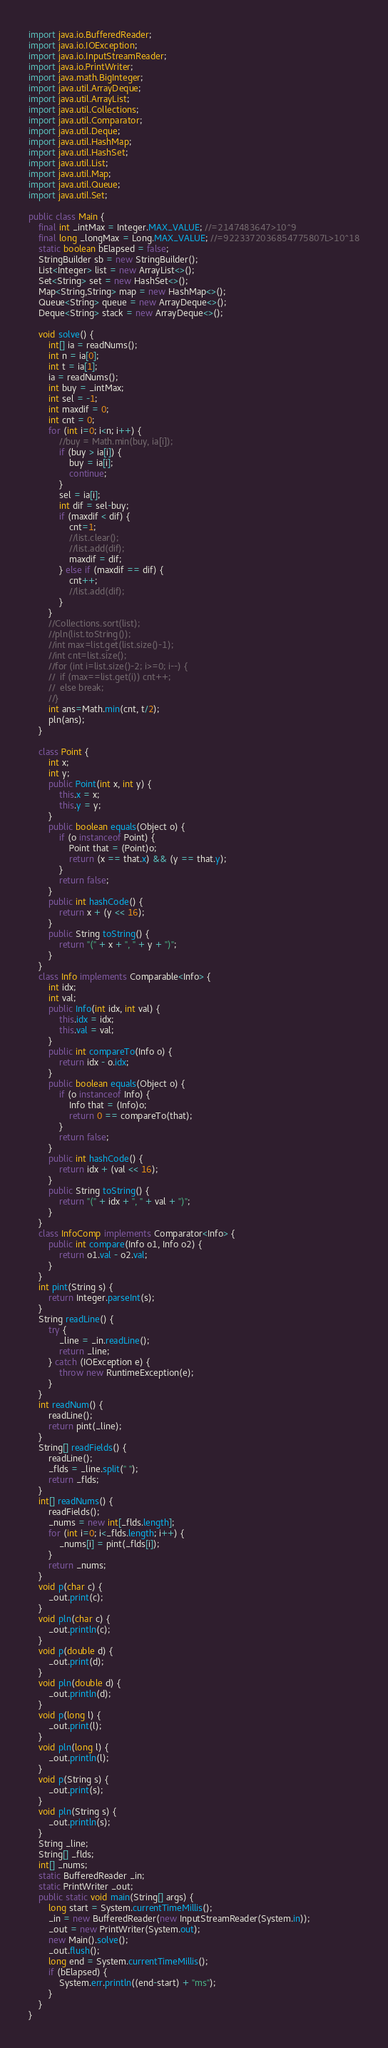<code> <loc_0><loc_0><loc_500><loc_500><_Java_>import java.io.BufferedReader;
import java.io.IOException;
import java.io.InputStreamReader;
import java.io.PrintWriter;
import java.math.BigInteger;
import java.util.ArrayDeque;
import java.util.ArrayList;
import java.util.Collections;
import java.util.Comparator;
import java.util.Deque;
import java.util.HashMap;
import java.util.HashSet;
import java.util.List;
import java.util.Map;
import java.util.Queue;
import java.util.Set;

public class Main {
	final int _intMax = Integer.MAX_VALUE; //=2147483647>10^9
	final long _longMax = Long.MAX_VALUE; //=9223372036854775807L>10^18
	static boolean bElapsed = false;
	StringBuilder sb = new StringBuilder();
	List<Integer> list = new ArrayList<>();
	Set<String> set = new HashSet<>();
	Map<String,String> map = new HashMap<>();
	Queue<String> queue = new ArrayDeque<>();
	Deque<String> stack = new ArrayDeque<>();

	void solve() {
		int[] ia = readNums();
		int n = ia[0];
		int t = ia[1];
		ia = readNums();
		int buy = _intMax;
		int sel = -1;
		int maxdif = 0;
		int cnt = 0;
		for (int i=0; i<n; i++) {
			//buy = Math.min(buy, ia[i]);
			if (buy > ia[i]) {
				buy = ia[i];
				continue;
			}
			sel = ia[i];
			int dif = sel-buy;
			if (maxdif < dif) {
				cnt=1;
				//list.clear();
				//list.add(dif);
				maxdif = dif;
			} else if (maxdif == dif) {
				cnt++;
				//list.add(dif);
			}
		}
		//Collections.sort(list);
		//pln(list.toString());
		//int max=list.get(list.size()-1);
		//int cnt=list.size();
		//for (int i=list.size()-2; i>=0; i--) {
		//	if (max==list.get(i)) cnt++;
		//	else break;
		//}
		int ans=Math.min(cnt, t/2);
		pln(ans);
	}

	class Point {
		int x;
		int y;
		public Point(int x, int y) {
			this.x = x;
			this.y = y;
		}
		public boolean equals(Object o) {
			if (o instanceof Point) {
				Point that = (Point)o;
				return (x == that.x) && (y == that.y);
			}
			return false;
		}
		public int hashCode() {
			return x + (y << 16);
		}
		public String toString() {
			return "(" + x + ", " + y + ")";
		}
	}
	class Info implements Comparable<Info> {
		int idx;
		int val;
		public Info(int idx, int val) {
			this.idx = idx;
			this.val = val;
		}
		public int compareTo(Info o) {
			return idx - o.idx;
		}
		public boolean equals(Object o) {
			if (o instanceof Info) {
				Info that = (Info)o;
				return 0 == compareTo(that);
			}
			return false;
		}
		public int hashCode() {
			return idx + (val << 16);
		}
		public String toString() {
			return "(" + idx + ", " + val + ")";
		}
	}
	class InfoComp implements Comparator<Info> {
		public int compare(Info o1, Info o2) {
			return o1.val - o2.val;
		}
	}
	int pint(String s) {
		return Integer.parseInt(s);
	}
	String readLine() {
		try {
			_line = _in.readLine();
			return _line;
		} catch (IOException e) {
			throw new RuntimeException(e);
		}
	}
	int readNum() {
		readLine();
		return pint(_line);
	}
	String[] readFields() {
		readLine();
		_flds = _line.split(" ");
		return _flds;
	}
	int[] readNums() {
		readFields();
		_nums = new int[_flds.length];
		for (int i=0; i<_flds.length; i++) {
			_nums[i] = pint(_flds[i]);
		}
		return _nums;
	}
	void p(char c) {
		_out.print(c);
	}
	void pln(char c) {
		_out.println(c);
	}
	void p(double d) {
		_out.print(d);
	}
	void pln(double d) {
		_out.println(d);
	}
	void p(long l) {
		_out.print(l);
	}
	void pln(long l) {
		_out.println(l);
	}
	void p(String s) {
		_out.print(s);
	}
	void pln(String s) {
		_out.println(s);
	}
	String _line;
	String[] _flds;
	int[] _nums;
	static BufferedReader _in;
	static PrintWriter _out;
	public static void main(String[] args) {
		long start = System.currentTimeMillis();
		_in = new BufferedReader(new InputStreamReader(System.in));
		_out = new PrintWriter(System.out);
		new Main().solve();
		_out.flush();
		long end = System.currentTimeMillis();
		if (bElapsed) {
			System.err.println((end-start) + "ms");
		}
	}
}
</code> 